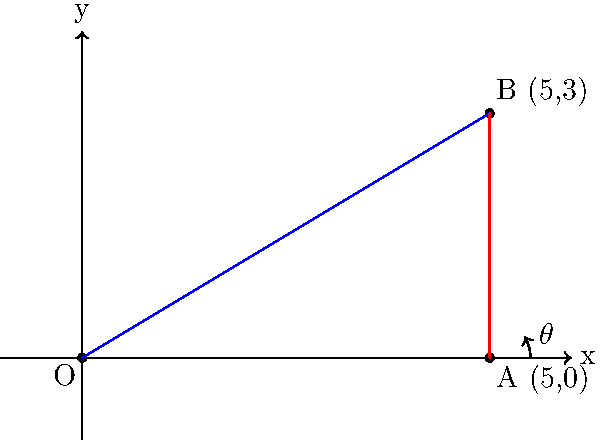A tennis player is practicing their serve on a coordinate plane. The player serves from point O (0,0) and the ball lands at point B (5,3). Calculate the angle $\theta$ of the serve with respect to the horizontal axis, rounded to the nearest degree. To find the angle of the serve, we can use the arctangent function. Here's how:

1) The serve forms a right triangle with the x-axis as its base and the path of the ball as its hypotenuse.

2) We can find the angle using the arctangent of the ratio of the opposite side to the adjacent side.

3) The opposite side is the y-coordinate of point B: 3
   The adjacent side is the x-coordinate of point B: 5

4) Therefore, $\theta = \arctan(\frac{3}{5})$

5) Using a calculator or programming function:
   $\theta = \arctan(\frac{3}{5}) \approx 0.5404195 \text{ radians}$

6) Convert radians to degrees:
   $\theta = 0.5404195 \times \frac{180}{\pi} \approx 30.96375 \text{ degrees}$

7) Rounding to the nearest degree:
   $\theta \approx 31 \text{ degrees}$
Answer: $31^\circ$ 